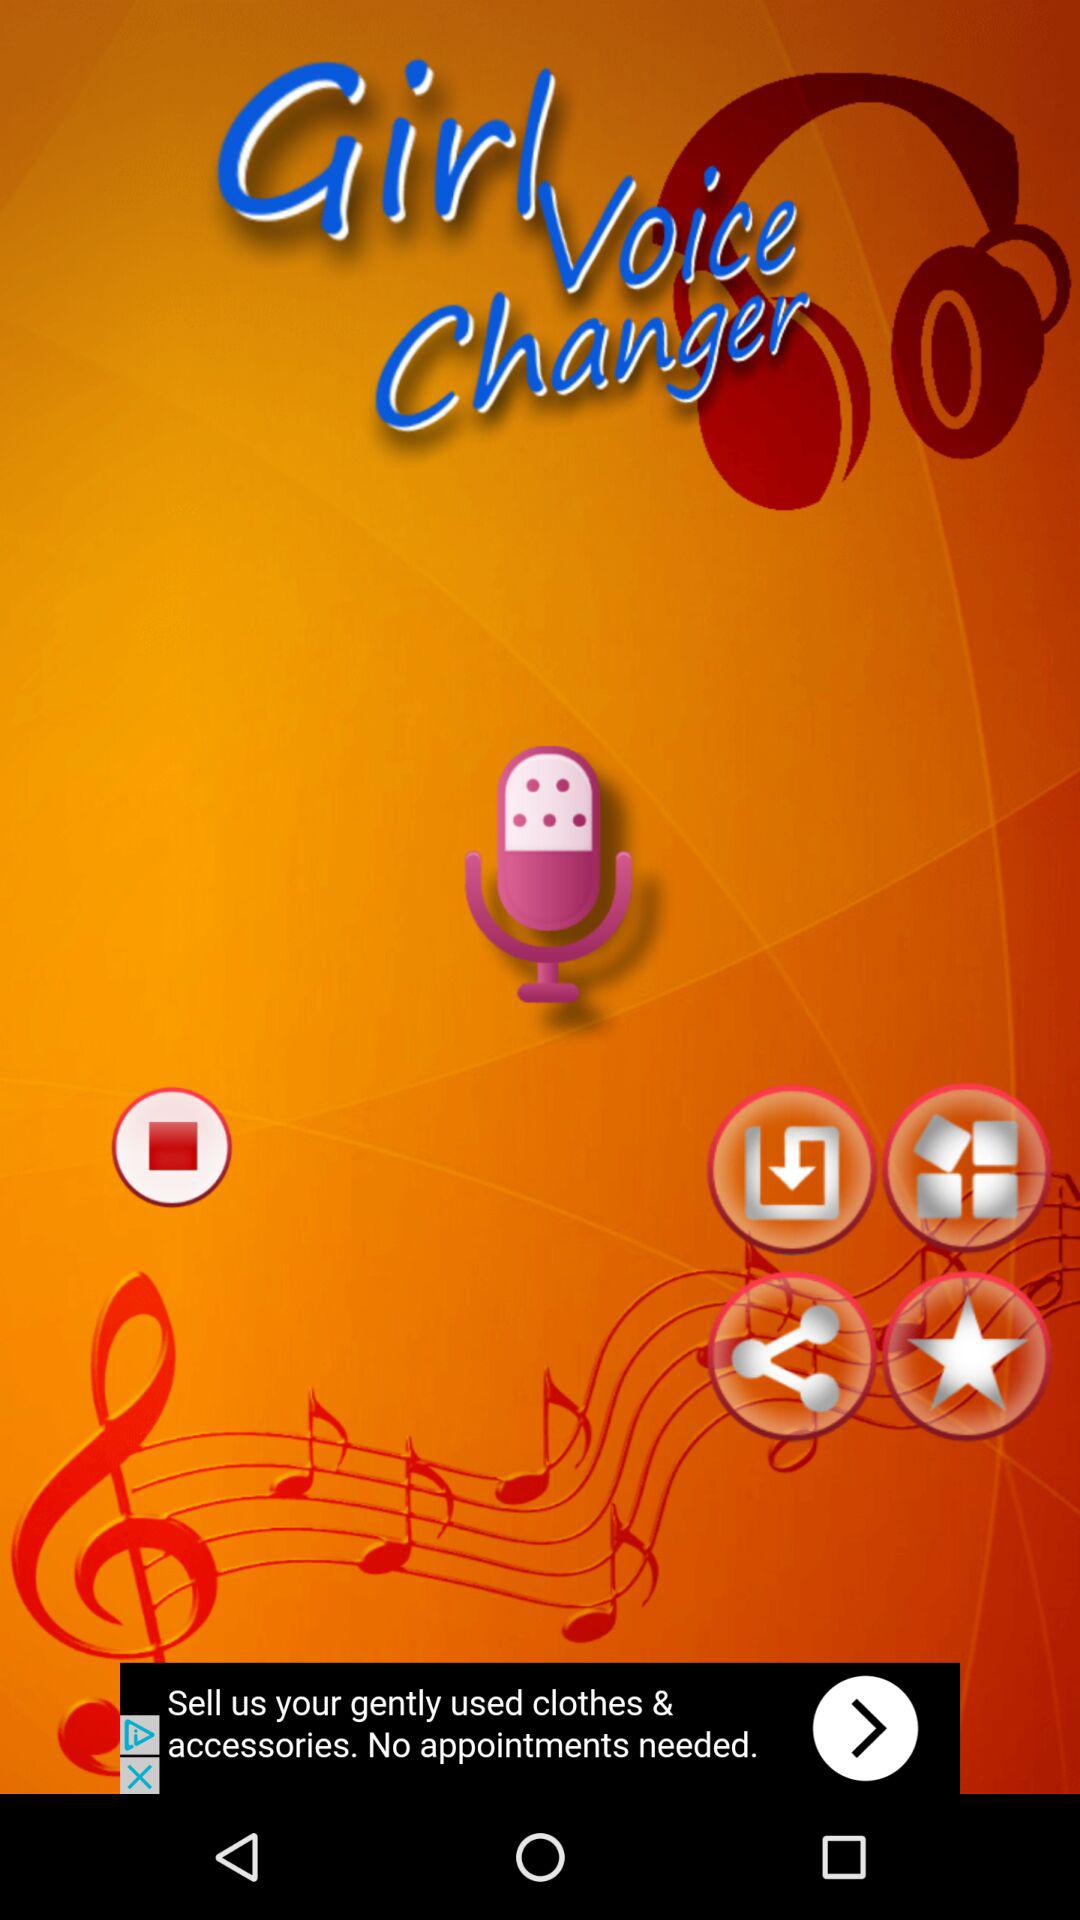What is the application name? The application name is "Girl Voice Changer". 